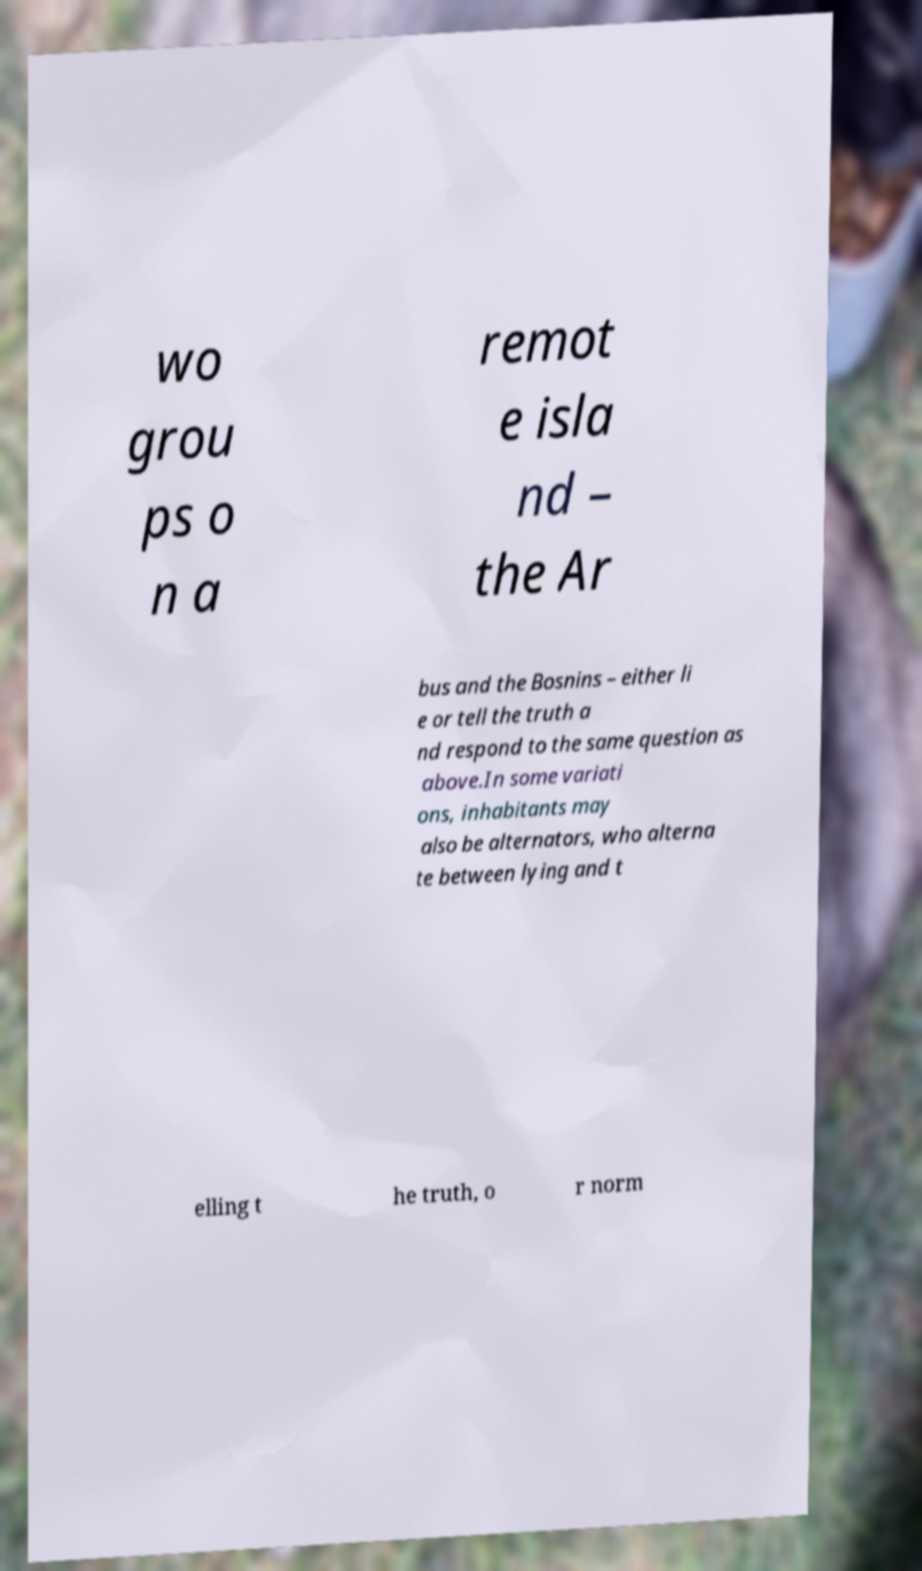Please identify and transcribe the text found in this image. wo grou ps o n a remot e isla nd – the Ar bus and the Bosnins – either li e or tell the truth a nd respond to the same question as above.In some variati ons, inhabitants may also be alternators, who alterna te between lying and t elling t he truth, o r norm 